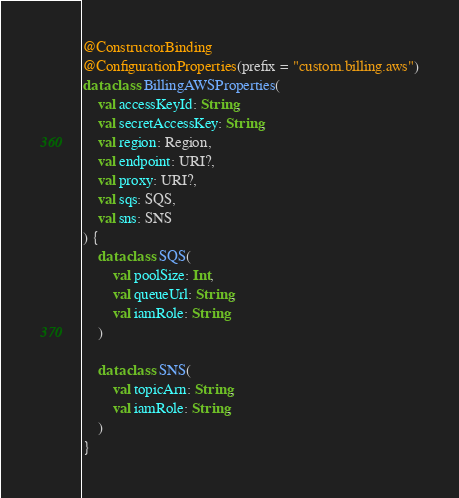<code> <loc_0><loc_0><loc_500><loc_500><_Kotlin_>
@ConstructorBinding
@ConfigurationProperties(prefix = "custom.billing.aws")
data class BillingAWSProperties(
    val accessKeyId: String,
    val secretAccessKey: String,
    val region: Region,
    val endpoint: URI?,
    val proxy: URI?,
    val sqs: SQS,
    val sns: SNS
) {
    data class SQS(
        val poolSize: Int,
        val queueUrl: String,
        val iamRole: String
    )

    data class SNS(
        val topicArn: String,
        val iamRole: String,
    )
}</code> 